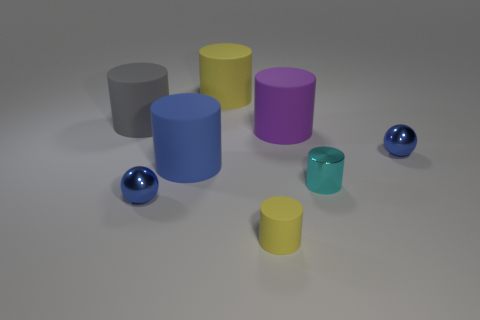Subtract all tiny cyan metal cylinders. How many cylinders are left? 5 Subtract all balls. How many objects are left? 6 Subtract 2 spheres. How many spheres are left? 0 Add 2 metal cylinders. How many objects exist? 10 Subtract all yellow cylinders. How many cylinders are left? 4 Add 7 big yellow cylinders. How many big yellow cylinders are left? 8 Add 5 spheres. How many spheres exist? 7 Subtract 0 purple cubes. How many objects are left? 8 Subtract all purple balls. Subtract all green cylinders. How many balls are left? 2 Subtract all yellow cubes. How many brown cylinders are left? 0 